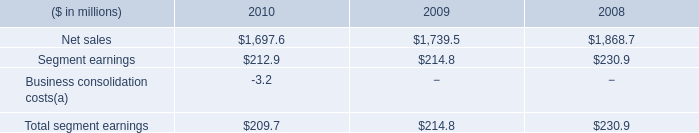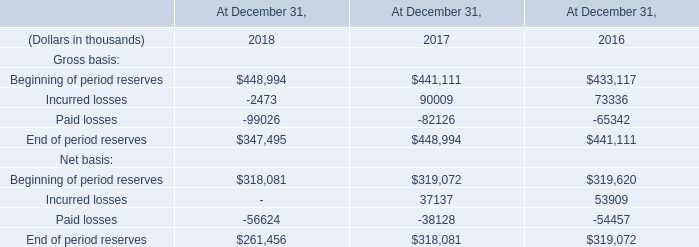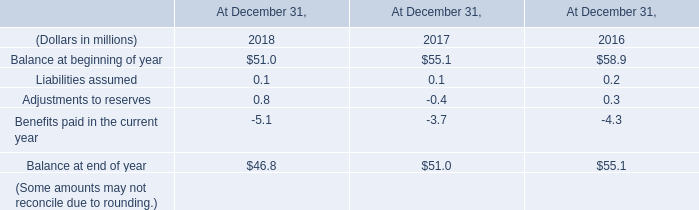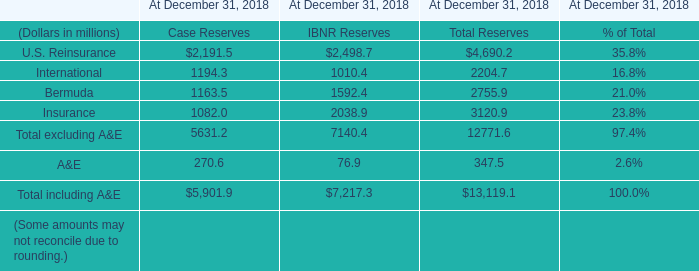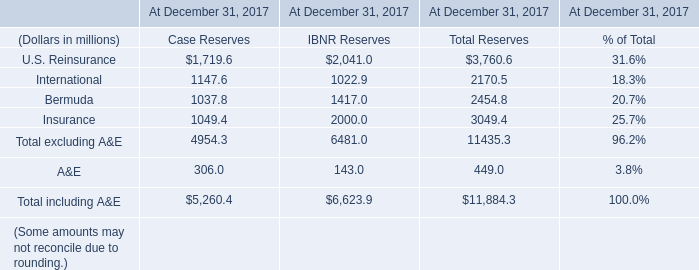What is the sum of Case Reserves in 2017 for At December 31, 2017? (in million) 
Computations: ((((1719.6 + 1147.6) + 1037.8) + 1049.4) + 306.0)
Answer: 5260.4. 